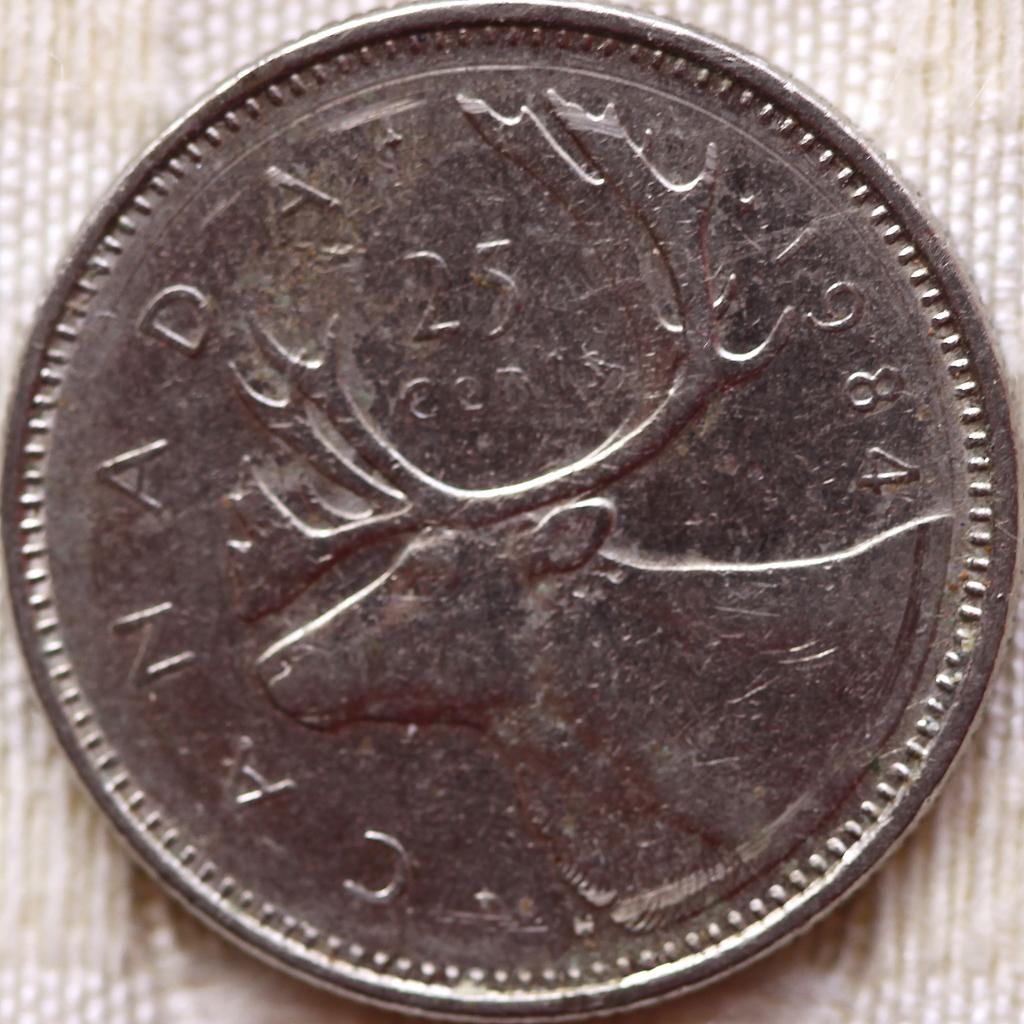<image>
Describe the image concisely. A 25 cent piece from Canada made in 1984. 